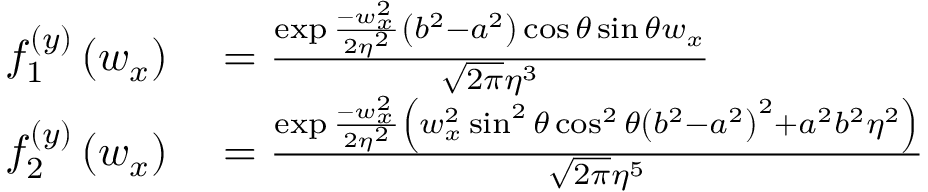Convert formula to latex. <formula><loc_0><loc_0><loc_500><loc_500>\begin{array} { r l } { f _ { 1 } ^ { ( y ) } \left ( w _ { x } \right ) } & = \frac { \exp \frac { - w _ { x } ^ { 2 } } { 2 \eta ^ { 2 } } \left ( b ^ { 2 } - a ^ { 2 } \right ) \cos \theta \sin \theta w _ { x } } { \sqrt { 2 \pi } \eta ^ { 3 } } } \\ { f _ { 2 } ^ { ( y ) } \left ( w _ { x } \right ) } & = \frac { \exp \frac { - w _ { x } ^ { 2 } } { 2 \eta ^ { 2 } } \left ( w _ { x } ^ { 2 } \sin ^ { 2 } \theta \cos ^ { 2 } \theta \left ( b ^ { 2 } - a ^ { 2 } \right ) ^ { 2 } + a ^ { 2 } b ^ { 2 } \eta ^ { 2 } \right ) } { \sqrt { 2 \pi } \eta ^ { 5 } } } \end{array}</formula> 